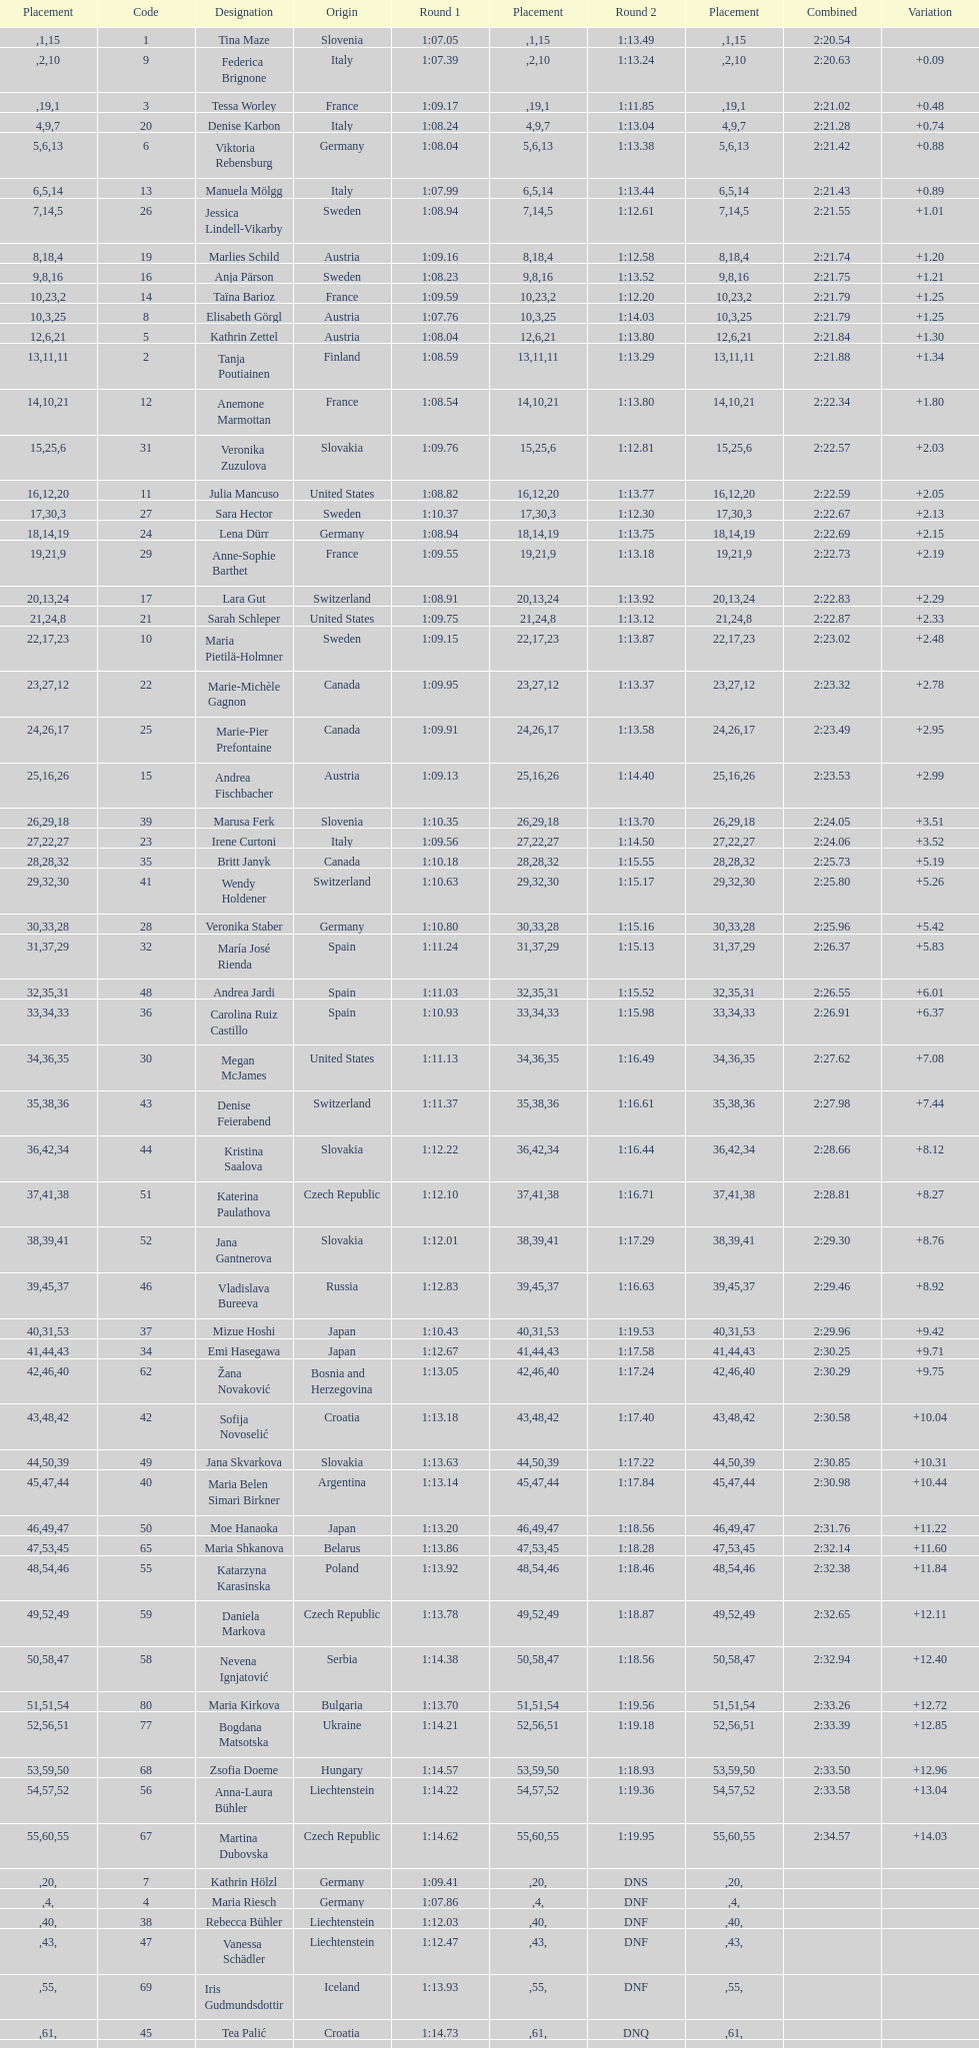Who was the last competitor to actually finish both runs? Martina Dubovska. 